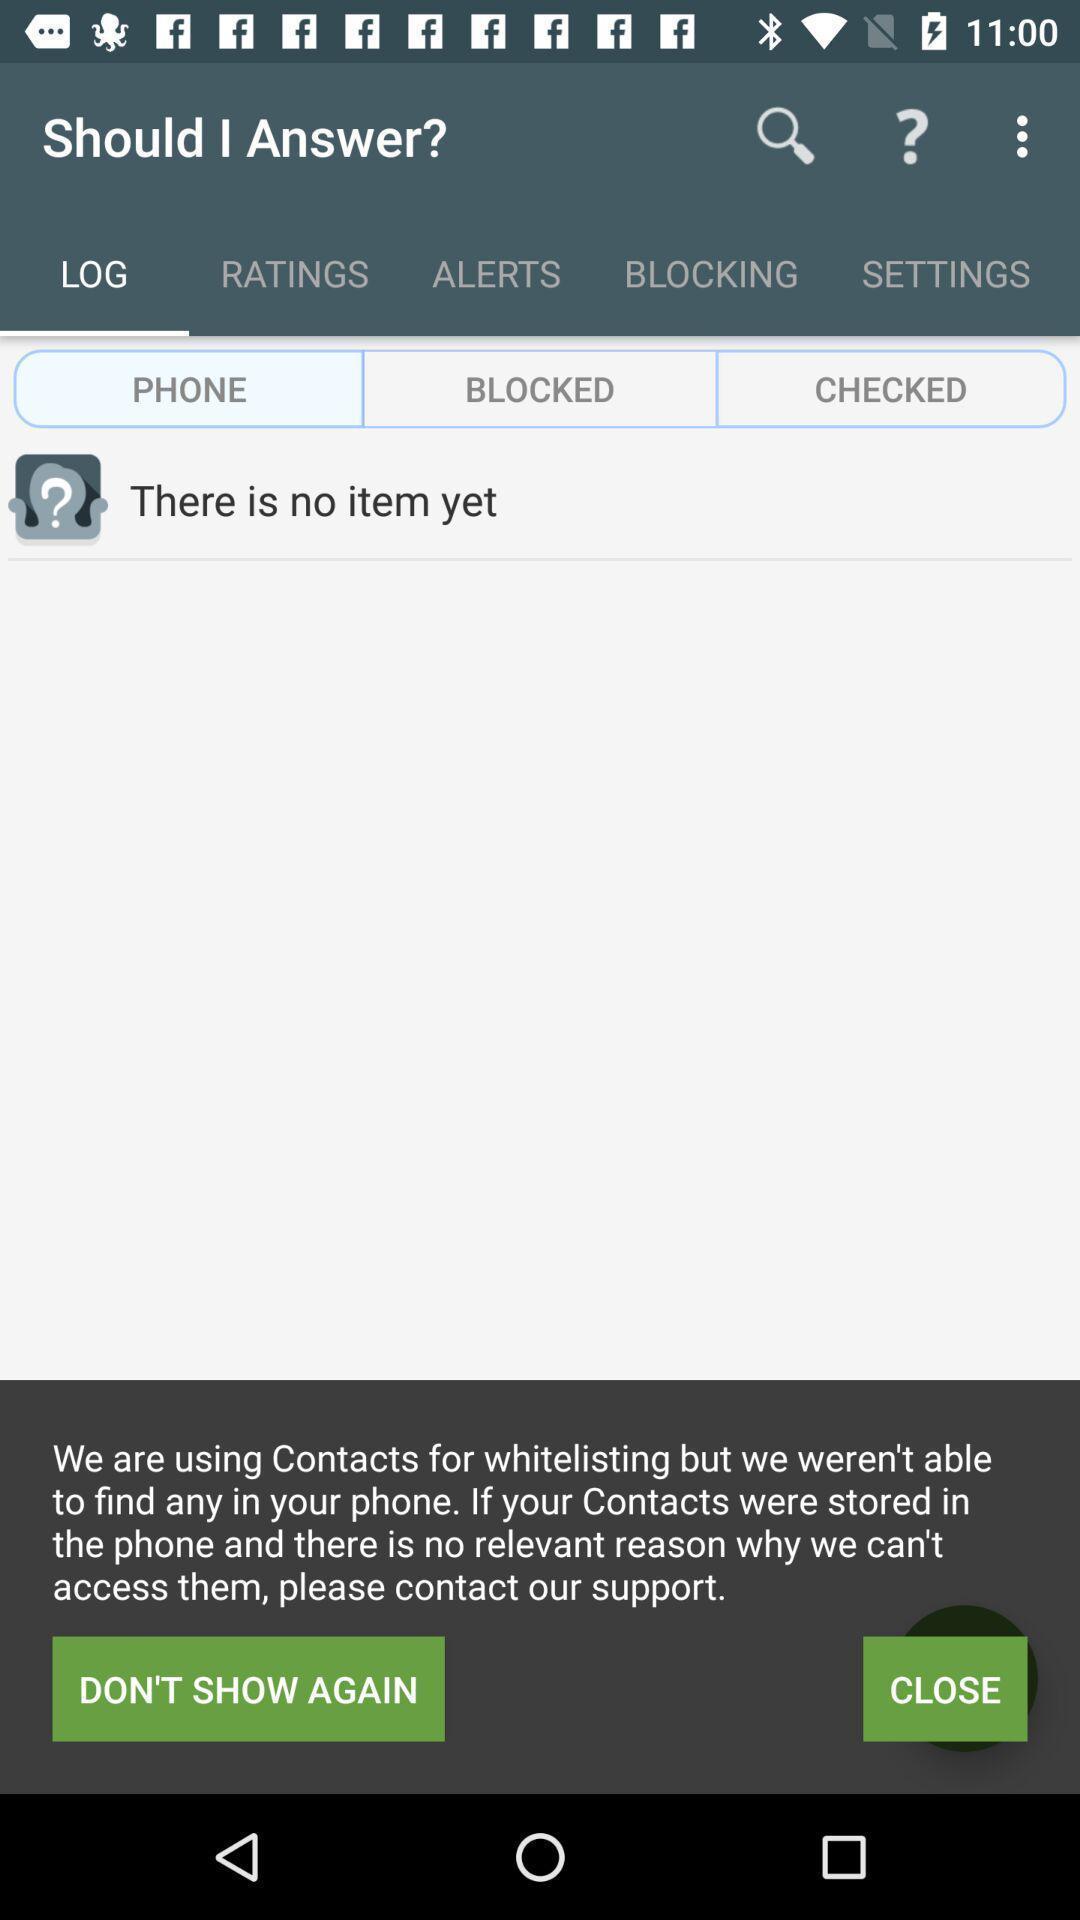Please provide a description for this image. Page showing there is no item yet. 